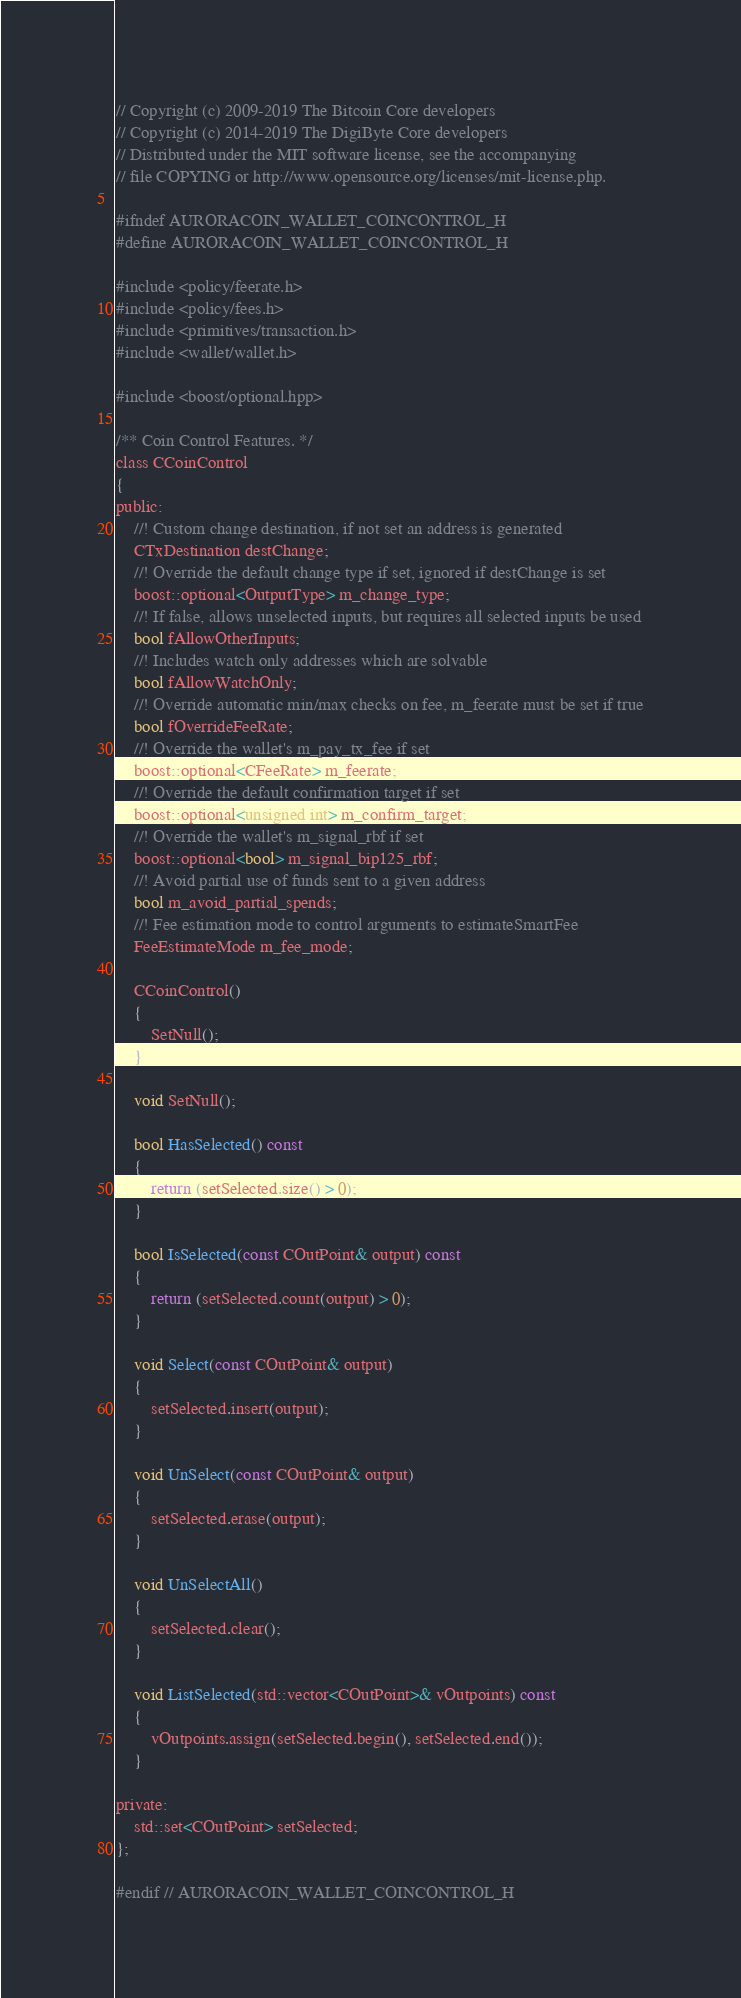Convert code to text. <code><loc_0><loc_0><loc_500><loc_500><_C_>// Copyright (c) 2009-2019 The Bitcoin Core developers
// Copyright (c) 2014-2019 The DigiByte Core developers
// Distributed under the MIT software license, see the accompanying
// file COPYING or http://www.opensource.org/licenses/mit-license.php.

#ifndef AURORACOIN_WALLET_COINCONTROL_H
#define AURORACOIN_WALLET_COINCONTROL_H

#include <policy/feerate.h>
#include <policy/fees.h>
#include <primitives/transaction.h>
#include <wallet/wallet.h>

#include <boost/optional.hpp>

/** Coin Control Features. */
class CCoinControl
{
public:
    //! Custom change destination, if not set an address is generated
    CTxDestination destChange;
    //! Override the default change type if set, ignored if destChange is set
    boost::optional<OutputType> m_change_type;
    //! If false, allows unselected inputs, but requires all selected inputs be used
    bool fAllowOtherInputs;
    //! Includes watch only addresses which are solvable
    bool fAllowWatchOnly;
    //! Override automatic min/max checks on fee, m_feerate must be set if true
    bool fOverrideFeeRate;
    //! Override the wallet's m_pay_tx_fee if set
    boost::optional<CFeeRate> m_feerate;
    //! Override the default confirmation target if set
    boost::optional<unsigned int> m_confirm_target;
    //! Override the wallet's m_signal_rbf if set
    boost::optional<bool> m_signal_bip125_rbf;
    //! Avoid partial use of funds sent to a given address
    bool m_avoid_partial_spends;
    //! Fee estimation mode to control arguments to estimateSmartFee
    FeeEstimateMode m_fee_mode;

    CCoinControl()
    {
        SetNull();
    }

    void SetNull();

    bool HasSelected() const
    {
        return (setSelected.size() > 0);
    }

    bool IsSelected(const COutPoint& output) const
    {
        return (setSelected.count(output) > 0);
    }

    void Select(const COutPoint& output)
    {
        setSelected.insert(output);
    }

    void UnSelect(const COutPoint& output)
    {
        setSelected.erase(output);
    }

    void UnSelectAll()
    {
        setSelected.clear();
    }

    void ListSelected(std::vector<COutPoint>& vOutpoints) const
    {
        vOutpoints.assign(setSelected.begin(), setSelected.end());
    }

private:
    std::set<COutPoint> setSelected;
};

#endif // AURORACOIN_WALLET_COINCONTROL_H
</code> 